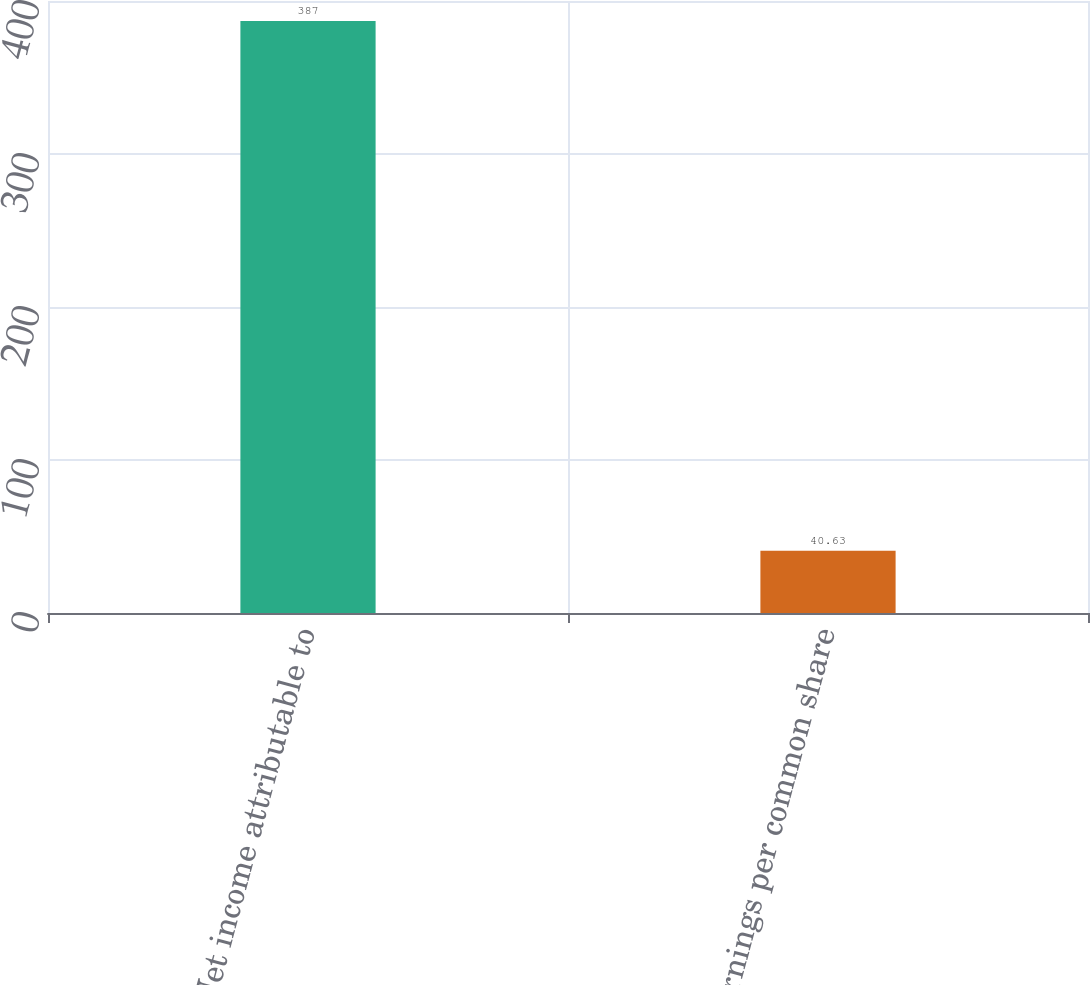Convert chart. <chart><loc_0><loc_0><loc_500><loc_500><bar_chart><fcel>Net income attributable to<fcel>Earnings per common share<nl><fcel>387<fcel>40.63<nl></chart> 